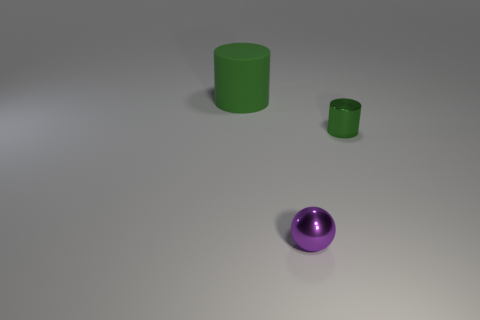Add 1 purple spheres. How many objects exist? 4 Subtract 0 yellow cubes. How many objects are left? 3 Subtract all spheres. How many objects are left? 2 Subtract 1 balls. How many balls are left? 0 Subtract all yellow cylinders. Subtract all purple balls. How many cylinders are left? 2 Subtract all yellow spheres. How many cyan cylinders are left? 0 Subtract all tiny cyan metal cylinders. Subtract all green cylinders. How many objects are left? 1 Add 1 green matte objects. How many green matte objects are left? 2 Add 3 large green cylinders. How many large green cylinders exist? 4 